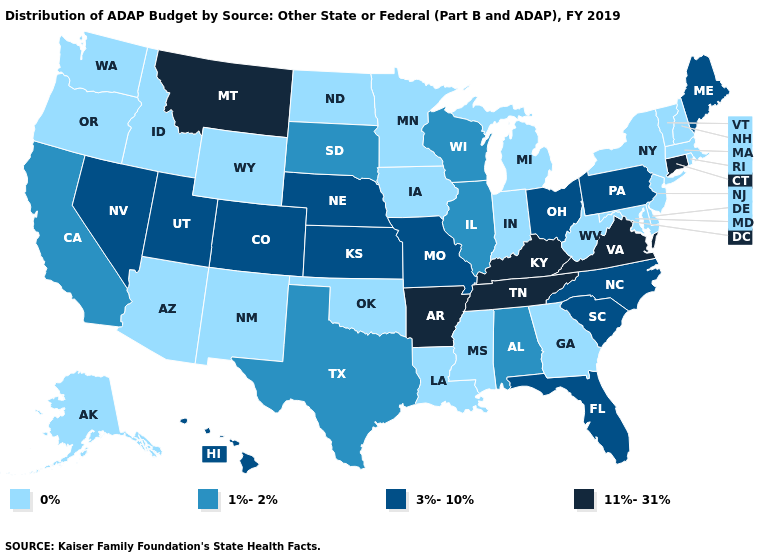Which states have the lowest value in the Northeast?
Short answer required. Massachusetts, New Hampshire, New Jersey, New York, Rhode Island, Vermont. Does Tennessee have the lowest value in the South?
Concise answer only. No. Does New Hampshire have the lowest value in the USA?
Answer briefly. Yes. Is the legend a continuous bar?
Give a very brief answer. No. Does the first symbol in the legend represent the smallest category?
Write a very short answer. Yes. Does Connecticut have the highest value in the USA?
Short answer required. Yes. Among the states that border Tennessee , does Missouri have the lowest value?
Be succinct. No. Does the first symbol in the legend represent the smallest category?
Concise answer only. Yes. Does South Dakota have a lower value than New Mexico?
Answer briefly. No. What is the value of Washington?
Keep it brief. 0%. How many symbols are there in the legend?
Give a very brief answer. 4. Which states hav the highest value in the South?
Be succinct. Arkansas, Kentucky, Tennessee, Virginia. Does Alabama have the lowest value in the USA?
Write a very short answer. No. Name the states that have a value in the range 1%-2%?
Short answer required. Alabama, California, Illinois, South Dakota, Texas, Wisconsin. 